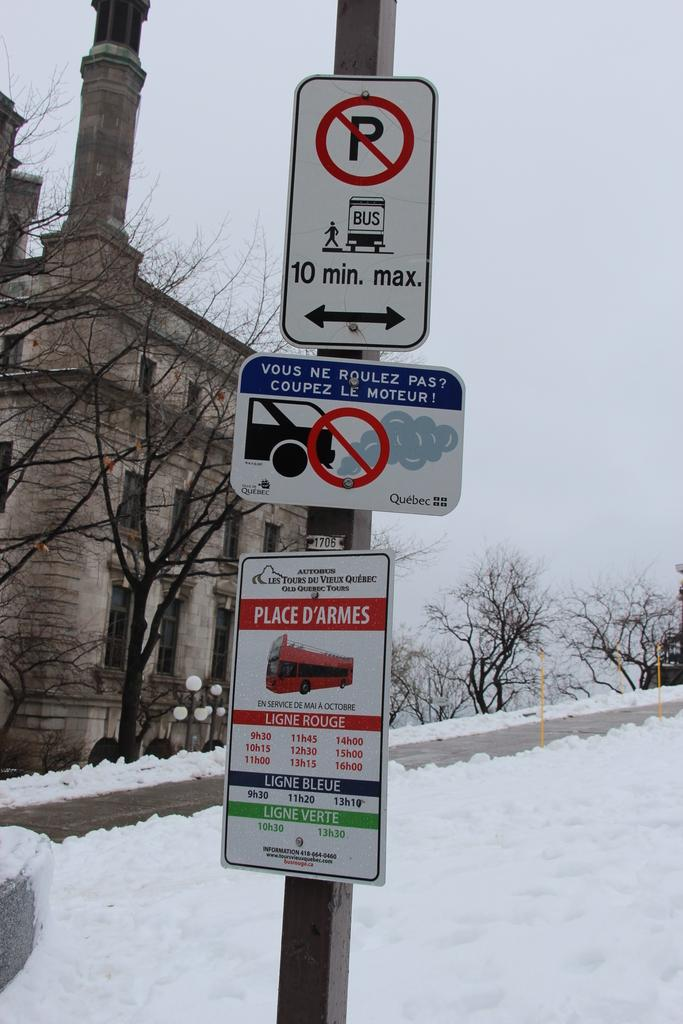<image>
Describe the image concisely. No Parking sign that says 10 min max and the landscape is covered in snow. 